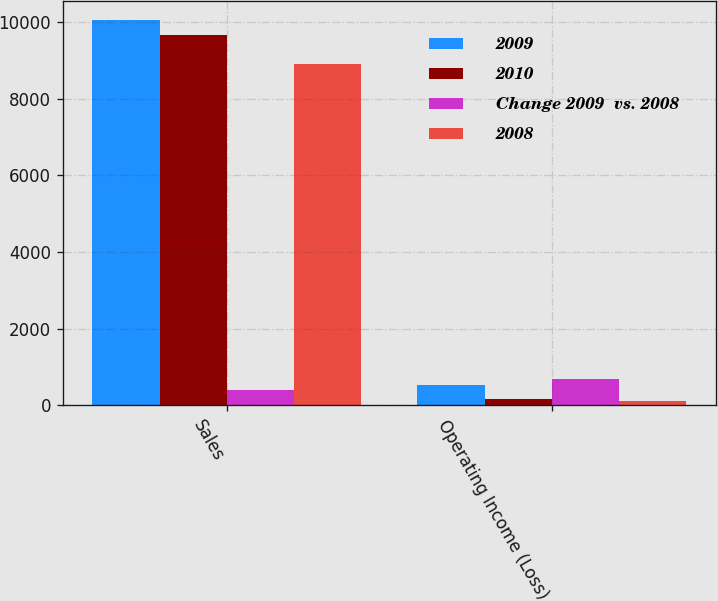<chart> <loc_0><loc_0><loc_500><loc_500><stacked_bar_chart><ecel><fcel>Sales<fcel>Operating Income (Loss)<nl><fcel>2009<fcel>10062<fcel>519<nl><fcel>2010<fcel>9660<fcel>157<nl><fcel>Change 2009  vs. 2008<fcel>402<fcel>676<nl><fcel>2008<fcel>8900<fcel>118<nl></chart> 